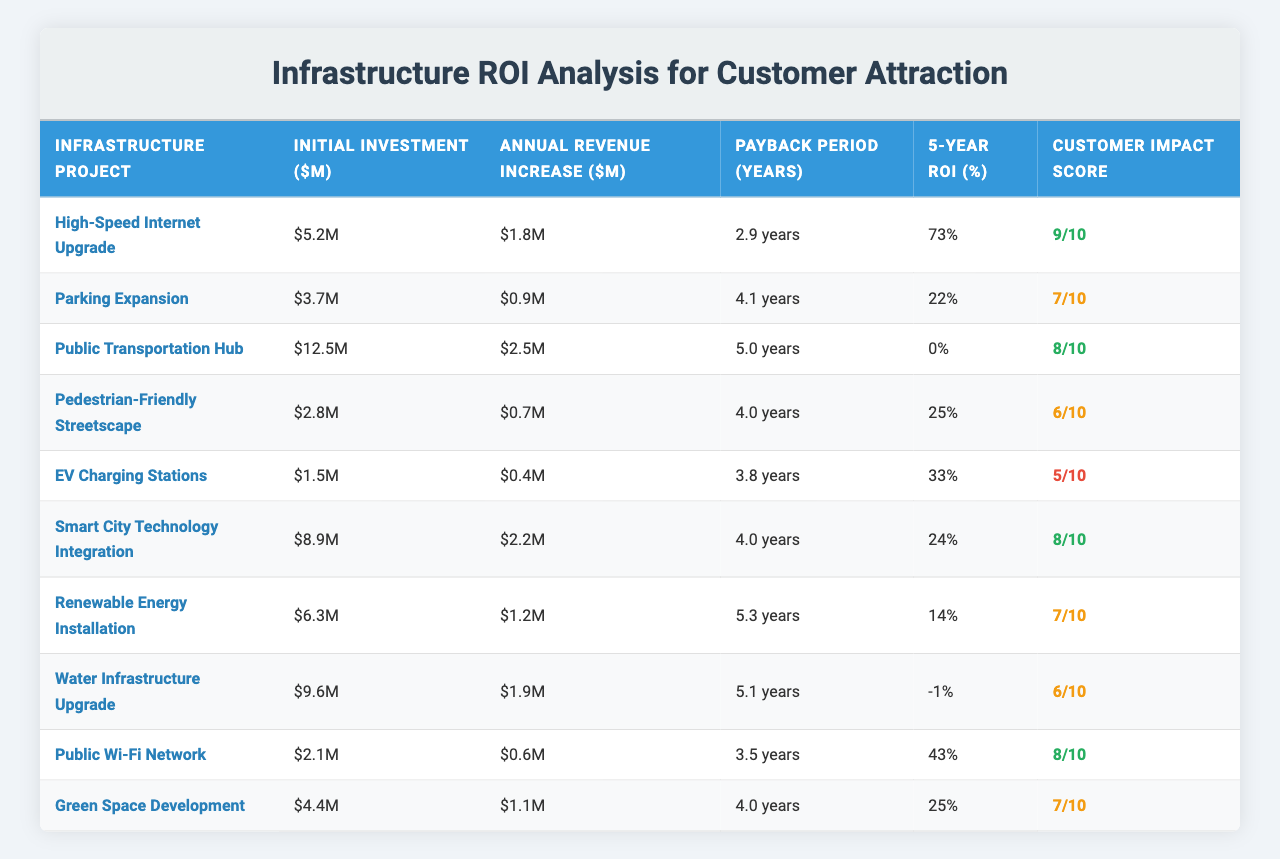What is the initial investment for the Public Transportation Hub project? The table lists the initial investment for the Public Transportation Hub project as $12.5 million.
Answer: $12.5 million Which project has the highest 5-Year ROI? By examining the table, the project with the highest 5-Year ROI is the High-Speed Internet Upgrade at 73%.
Answer: 73% Is the Payback Period for the EV Charging Stations greater than 3 years? The Payback Period for the EV Charging Stations is 3.8 years, which is indeed greater than 3 years.
Answer: Yes What is the average Annual Revenue Increase for projects with a Customer Impact Score of 8 or above? The projects with a Customer Impact Score of 8 are: High-Speed Internet Upgrade, Public Transportation Hub, Smart City Technology Integration, Public Wi-Fi Network. Their Annual Revenue Increases are 1.8, 2.5, 2.2, and 0.6. The average is (1.8 + 2.5 + 2.2 + 0.6) / 4 = 1.525 million.
Answer: $1.525 million Which project has the lowest Customer Impact Score? The project with the lowest Customer Impact Score is the EV Charging Stations, with a score of 5.
Answer: 5 Does any project have a negative Payback Period? Looking at the table, the Water Infrastructure Upgrade has a Payback Period listed as -1, indicating a negative Payback Period.
Answer: Yes How many projects have a 5-Year ROI greater than 20%? By reviewing the table, the projects with a 5-Year ROI greater than 20% are: High-Speed Internet Upgrade (73%), Parking Expansion (22%), and Smart City Technology Integration (24%). Thus, there are 3 projects.
Answer: 3 What is the difference in Initial Investment between the Public Transportation Hub and the Parking Expansion? The Initial Investment for the Public Transportation Hub is $12.5 million and for the Parking Expansion, it is $3.7 million. The difference is 12.5 - 3.7 = 8.8 million.
Answer: $8.8 million Which project generates the highest Annual Revenue Increase? The Public Transportation Hub generates the highest Annual Revenue Increase with $2.5 million.
Answer: $2.5 million Is the Customer Impact Score directly correlated with the 5-Year ROI of the infrastructure projects? Analyzing the Customer Impact Scores and 5-Year ROIs shows variability; for instance, the Public Transportation Hub has a Customer Impact Score of 8 but a ROI of 0%, indicating no direct correlation.
Answer: No 